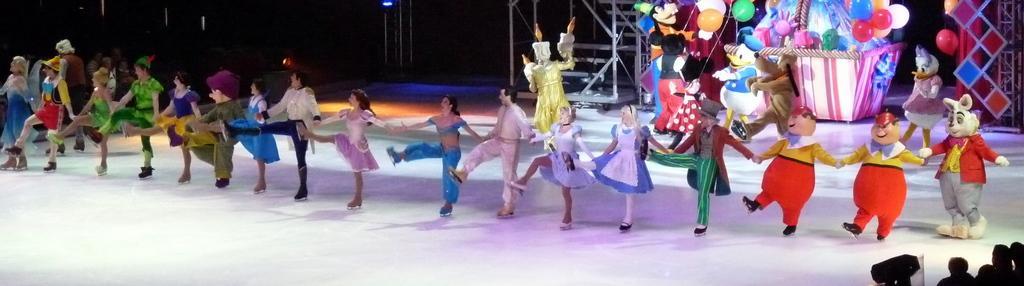How would you summarize this image in a sentence or two? In the image in the center, we can see a few people are performing and they are in different costumes. In the bottom right of the image, we can see a few people. In the background we can see the poles, balloons and some decorative items. 